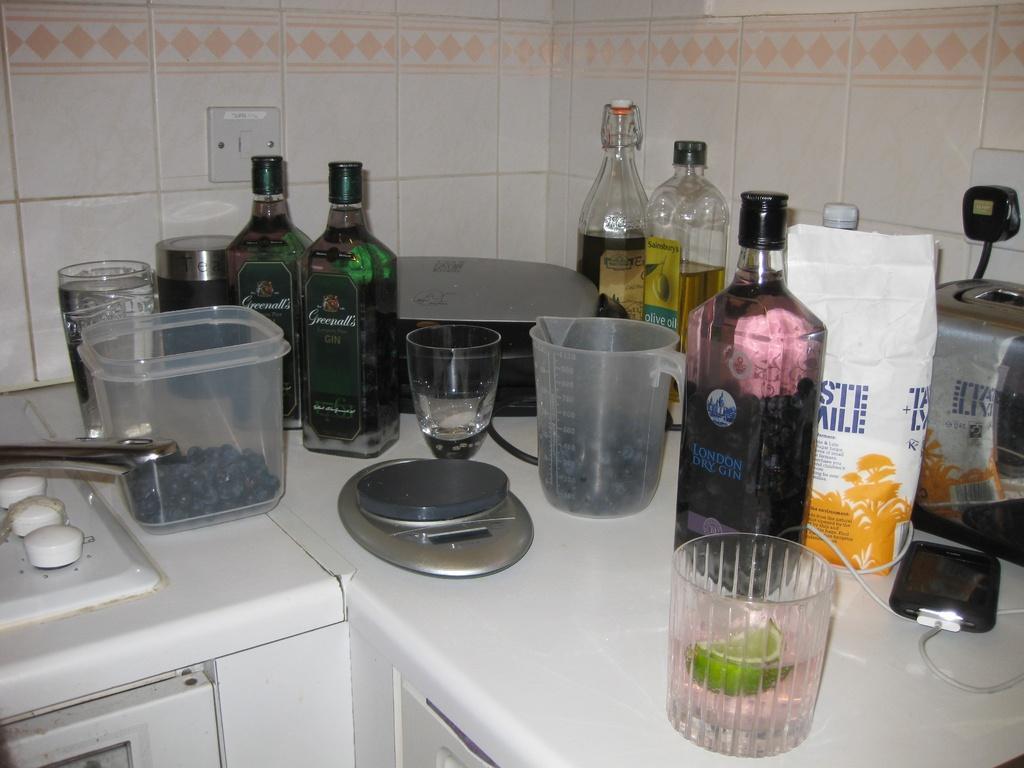Can you describe this image briefly? This picture is of inside. In the foreground we can see the glasses, jars and bottles placed on the top of the platform. In the background we can see a switch board and a wall. 